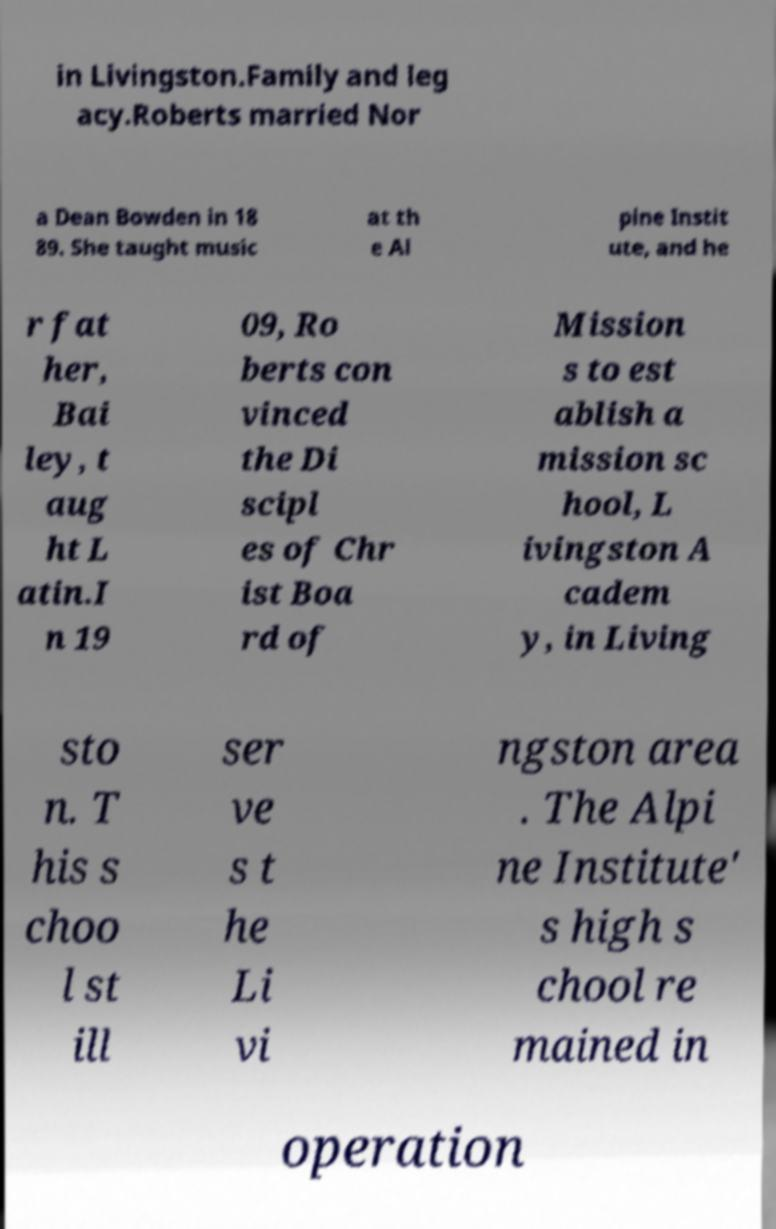Please identify and transcribe the text found in this image. in Livingston.Family and leg acy.Roberts married Nor a Dean Bowden in 18 89. She taught music at th e Al pine Instit ute, and he r fat her, Bai ley, t aug ht L atin.I n 19 09, Ro berts con vinced the Di scipl es of Chr ist Boa rd of Mission s to est ablish a mission sc hool, L ivingston A cadem y, in Living sto n. T his s choo l st ill ser ve s t he Li vi ngston area . The Alpi ne Institute' s high s chool re mained in operation 